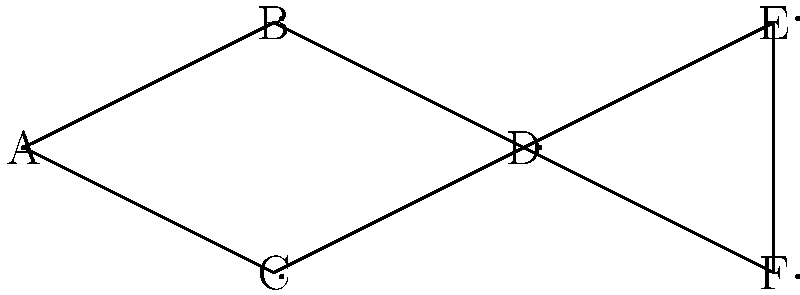At a VIP business dinner, six high-profile executives (A, B, C, D, E, and F) need to be seated. The graph represents their professional relationships, where an edge indicates a strong business connection. To maximize networking opportunities, you want to seat executives with no direct connection next to each other. What is the maximum number of such beneficial seat pairings possible in this arrangement? Let's approach this step-by-step:

1) First, we need to identify all pairs of executives who are not directly connected in the graph. These are:
   (A,D), (A,E), (A,F), (B,E), (B,F), (C,E), (C,F)

2) Now, we need to find the maximum number of these pairs that can be seated next to each other. This is equivalent to finding the maximum number of non-overlapping pairs.

3) We can start by selecting a pair and then removing all pairs that overlap with it:
   - If we choose (A,D), we can't use any other pairs involving A or D.
   - From the remaining pairs, we can choose (B,F) or (C,E).
   - Let's say we choose (B,F). Now we've used A, B, D, and F.
   - The only remaining pair is (C,E).

4) Thus, one optimal seating arrangement would be:
   A - D - B - F - C - E

5) This arrangement gives us 3 beneficial pairings: (A,D), (B,F), and (C,E).

6) We can verify that this is indeed the maximum by trying other combinations, but none will yield more than 3 beneficial pairings.

Therefore, the maximum number of beneficial seat pairings is 3.
Answer: 3 